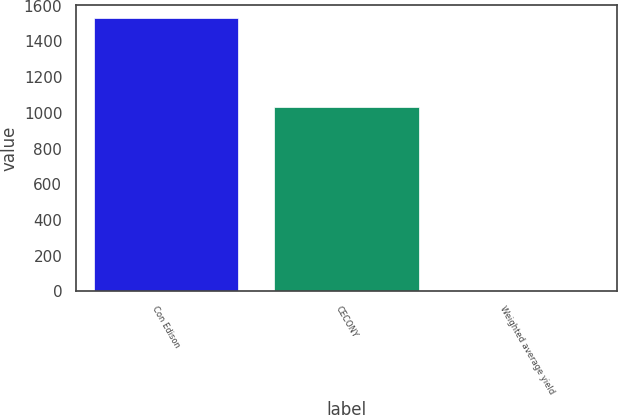Convert chart. <chart><loc_0><loc_0><loc_500><loc_500><bar_chart><fcel>Con Edison<fcel>CECONY<fcel>Weighted average yield<nl><fcel>1529<fcel>1033<fcel>0.7<nl></chart> 